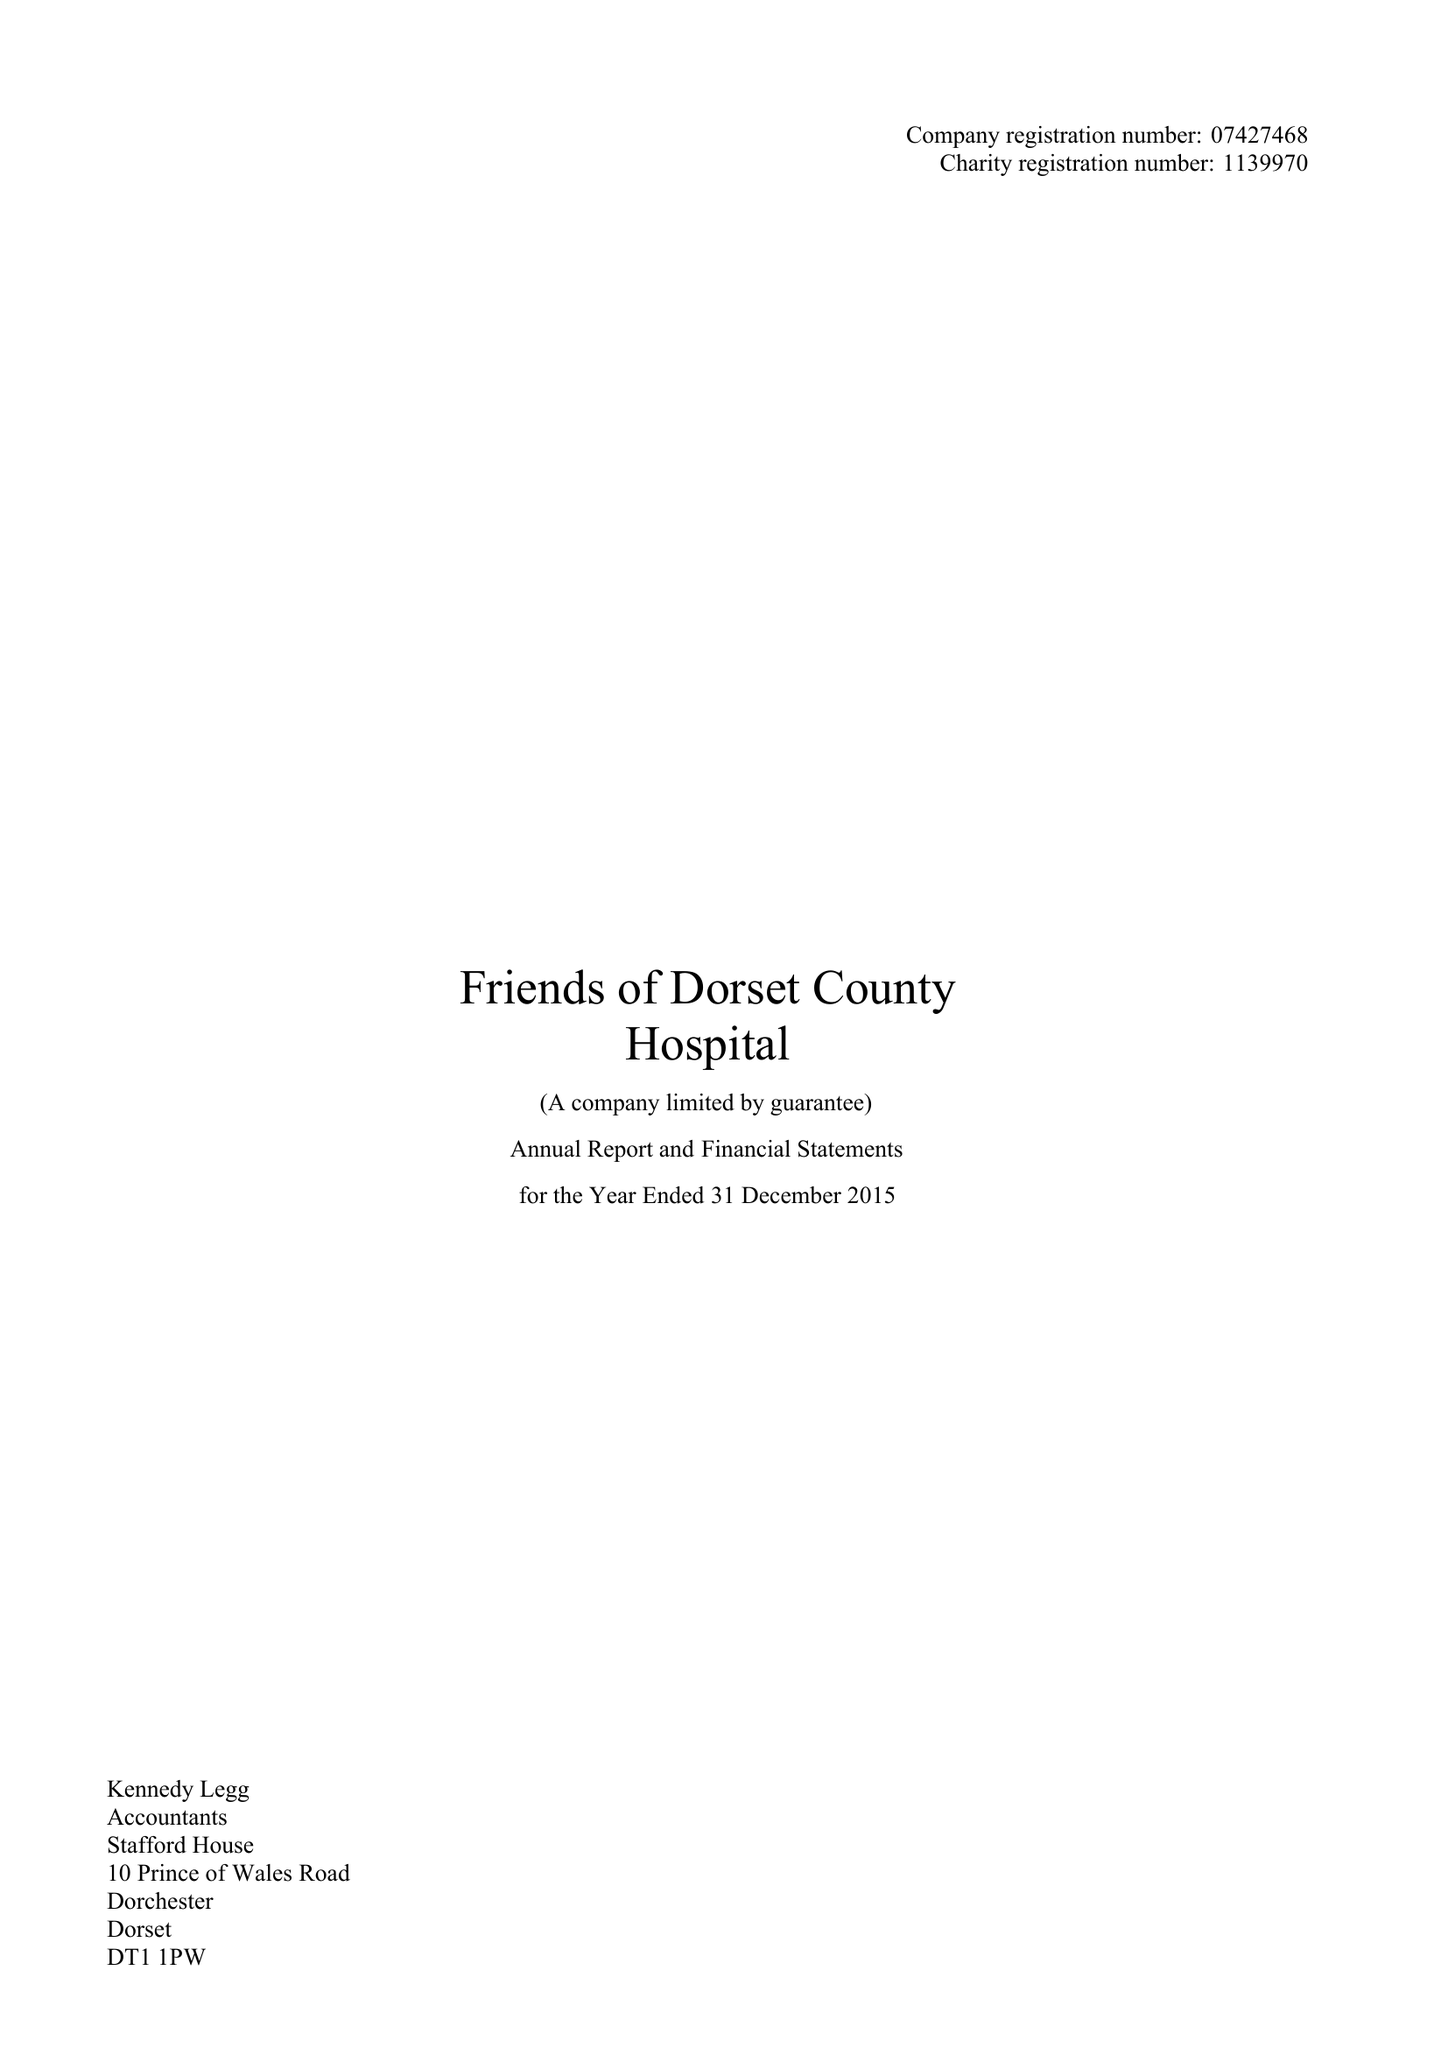What is the value for the spending_annually_in_british_pounds?
Answer the question using a single word or phrase. 164940.00 